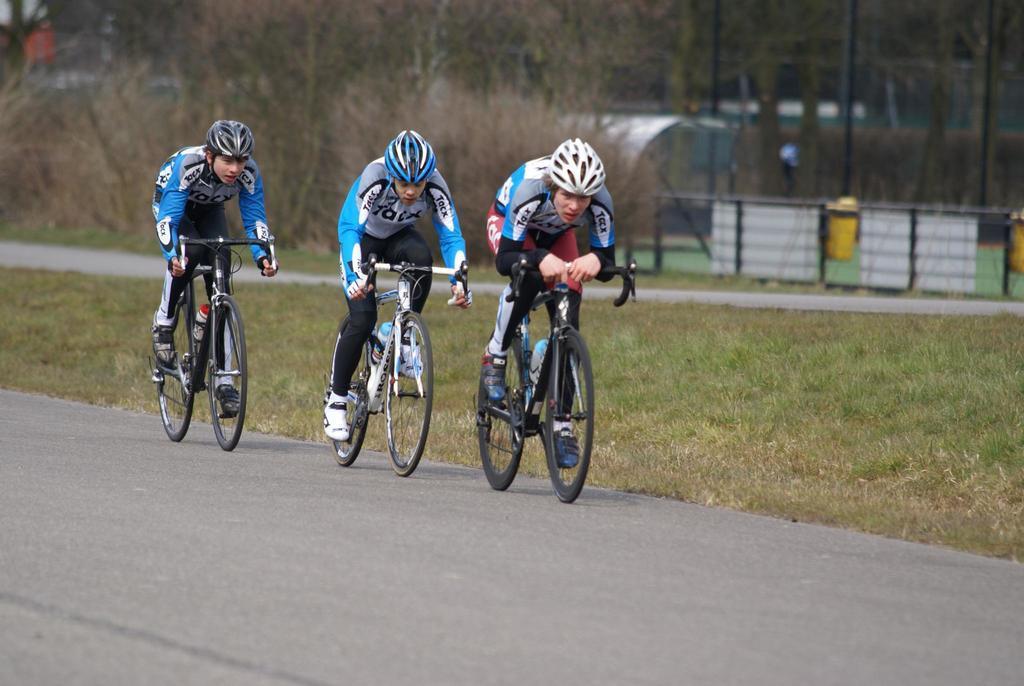Please provide a concise description of this image. In this image we can see three persons wearing sports dress, helmets riding bicycles and in the background of the image there are some trees, fencing, grass, iron rods and some boards. 